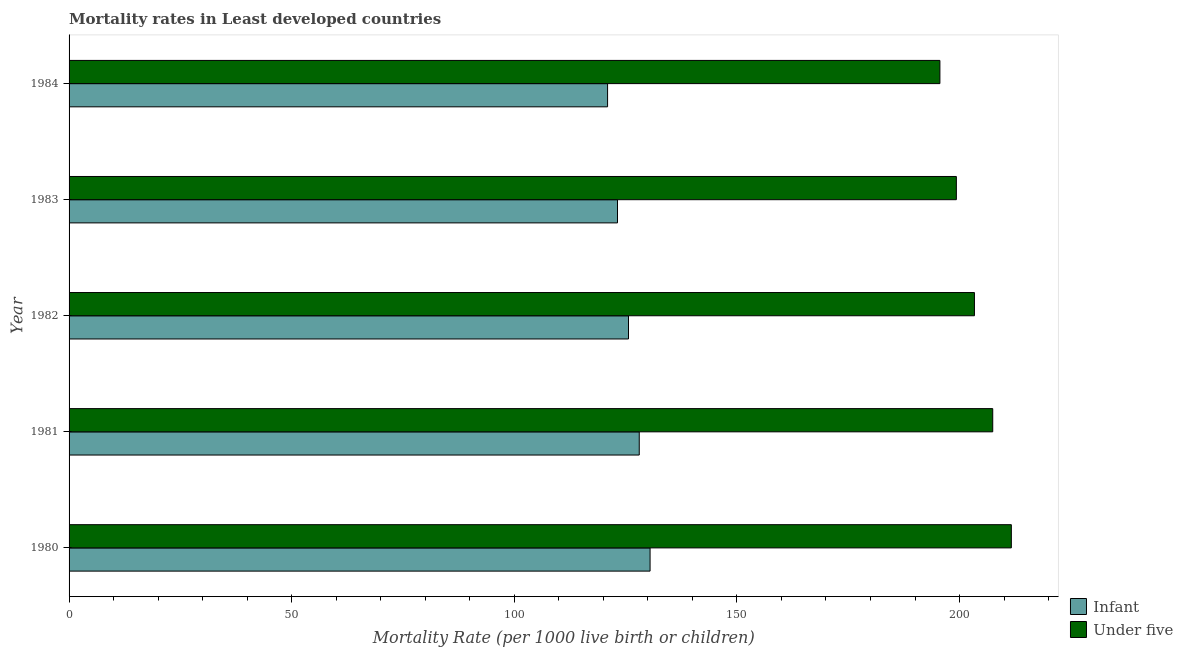How many groups of bars are there?
Your response must be concise. 5. Are the number of bars per tick equal to the number of legend labels?
Your answer should be very brief. Yes. What is the under-5 mortality rate in 1980?
Provide a short and direct response. 211.64. Across all years, what is the maximum infant mortality rate?
Ensure brevity in your answer.  130.5. Across all years, what is the minimum infant mortality rate?
Your answer should be compact. 120.95. In which year was the infant mortality rate maximum?
Ensure brevity in your answer.  1980. What is the total infant mortality rate in the graph?
Your response must be concise. 628.34. What is the difference between the under-5 mortality rate in 1980 and that in 1981?
Make the answer very short. 4.18. What is the difference between the under-5 mortality rate in 1981 and the infant mortality rate in 1984?
Your answer should be compact. 86.51. What is the average infant mortality rate per year?
Ensure brevity in your answer.  125.67. In the year 1983, what is the difference between the infant mortality rate and under-5 mortality rate?
Provide a short and direct response. -76.11. What is the ratio of the under-5 mortality rate in 1980 to that in 1981?
Provide a short and direct response. 1.02. Is the under-5 mortality rate in 1980 less than that in 1982?
Ensure brevity in your answer.  No. What is the difference between the highest and the second highest infant mortality rate?
Provide a succinct answer. 2.43. What is the difference between the highest and the lowest under-5 mortality rate?
Make the answer very short. 16.05. What does the 2nd bar from the top in 1981 represents?
Provide a short and direct response. Infant. What does the 2nd bar from the bottom in 1982 represents?
Make the answer very short. Under five. How many bars are there?
Make the answer very short. 10. Are the values on the major ticks of X-axis written in scientific E-notation?
Give a very brief answer. No. Does the graph contain any zero values?
Ensure brevity in your answer.  No. Where does the legend appear in the graph?
Your answer should be compact. Bottom right. How many legend labels are there?
Offer a terse response. 2. What is the title of the graph?
Make the answer very short. Mortality rates in Least developed countries. What is the label or title of the X-axis?
Give a very brief answer. Mortality Rate (per 1000 live birth or children). What is the Mortality Rate (per 1000 live birth or children) of Infant in 1980?
Keep it short and to the point. 130.5. What is the Mortality Rate (per 1000 live birth or children) of Under five in 1980?
Provide a succinct answer. 211.64. What is the Mortality Rate (per 1000 live birth or children) in Infant in 1981?
Ensure brevity in your answer.  128.06. What is the Mortality Rate (per 1000 live birth or children) in Under five in 1981?
Make the answer very short. 207.46. What is the Mortality Rate (per 1000 live birth or children) of Infant in 1982?
Offer a very short reply. 125.65. What is the Mortality Rate (per 1000 live birth or children) in Under five in 1982?
Offer a very short reply. 203.35. What is the Mortality Rate (per 1000 live birth or children) of Infant in 1983?
Offer a terse response. 123.18. What is the Mortality Rate (per 1000 live birth or children) in Under five in 1983?
Offer a terse response. 199.29. What is the Mortality Rate (per 1000 live birth or children) in Infant in 1984?
Give a very brief answer. 120.95. What is the Mortality Rate (per 1000 live birth or children) in Under five in 1984?
Ensure brevity in your answer.  195.59. Across all years, what is the maximum Mortality Rate (per 1000 live birth or children) in Infant?
Your answer should be compact. 130.5. Across all years, what is the maximum Mortality Rate (per 1000 live birth or children) in Under five?
Your answer should be compact. 211.64. Across all years, what is the minimum Mortality Rate (per 1000 live birth or children) of Infant?
Offer a terse response. 120.95. Across all years, what is the minimum Mortality Rate (per 1000 live birth or children) in Under five?
Offer a terse response. 195.59. What is the total Mortality Rate (per 1000 live birth or children) in Infant in the graph?
Your answer should be compact. 628.34. What is the total Mortality Rate (per 1000 live birth or children) of Under five in the graph?
Provide a succinct answer. 1017.33. What is the difference between the Mortality Rate (per 1000 live birth or children) of Infant in 1980 and that in 1981?
Provide a succinct answer. 2.43. What is the difference between the Mortality Rate (per 1000 live birth or children) of Under five in 1980 and that in 1981?
Provide a short and direct response. 4.18. What is the difference between the Mortality Rate (per 1000 live birth or children) of Infant in 1980 and that in 1982?
Your answer should be very brief. 4.85. What is the difference between the Mortality Rate (per 1000 live birth or children) of Under five in 1980 and that in 1982?
Offer a terse response. 8.29. What is the difference between the Mortality Rate (per 1000 live birth or children) of Infant in 1980 and that in 1983?
Ensure brevity in your answer.  7.32. What is the difference between the Mortality Rate (per 1000 live birth or children) of Under five in 1980 and that in 1983?
Your answer should be very brief. 12.35. What is the difference between the Mortality Rate (per 1000 live birth or children) in Infant in 1980 and that in 1984?
Offer a terse response. 9.54. What is the difference between the Mortality Rate (per 1000 live birth or children) of Under five in 1980 and that in 1984?
Your response must be concise. 16.05. What is the difference between the Mortality Rate (per 1000 live birth or children) of Infant in 1981 and that in 1982?
Offer a very short reply. 2.41. What is the difference between the Mortality Rate (per 1000 live birth or children) of Under five in 1981 and that in 1982?
Your answer should be very brief. 4.11. What is the difference between the Mortality Rate (per 1000 live birth or children) in Infant in 1981 and that in 1983?
Keep it short and to the point. 4.89. What is the difference between the Mortality Rate (per 1000 live birth or children) in Under five in 1981 and that in 1983?
Offer a terse response. 8.17. What is the difference between the Mortality Rate (per 1000 live birth or children) of Infant in 1981 and that in 1984?
Give a very brief answer. 7.11. What is the difference between the Mortality Rate (per 1000 live birth or children) in Under five in 1981 and that in 1984?
Ensure brevity in your answer.  11.87. What is the difference between the Mortality Rate (per 1000 live birth or children) of Infant in 1982 and that in 1983?
Offer a terse response. 2.47. What is the difference between the Mortality Rate (per 1000 live birth or children) of Under five in 1982 and that in 1983?
Provide a short and direct response. 4.06. What is the difference between the Mortality Rate (per 1000 live birth or children) of Infant in 1982 and that in 1984?
Provide a succinct answer. 4.7. What is the difference between the Mortality Rate (per 1000 live birth or children) in Under five in 1982 and that in 1984?
Your response must be concise. 7.76. What is the difference between the Mortality Rate (per 1000 live birth or children) of Infant in 1983 and that in 1984?
Offer a very short reply. 2.23. What is the difference between the Mortality Rate (per 1000 live birth or children) of Under five in 1983 and that in 1984?
Your answer should be compact. 3.7. What is the difference between the Mortality Rate (per 1000 live birth or children) of Infant in 1980 and the Mortality Rate (per 1000 live birth or children) of Under five in 1981?
Provide a succinct answer. -76.96. What is the difference between the Mortality Rate (per 1000 live birth or children) of Infant in 1980 and the Mortality Rate (per 1000 live birth or children) of Under five in 1982?
Make the answer very short. -72.85. What is the difference between the Mortality Rate (per 1000 live birth or children) in Infant in 1980 and the Mortality Rate (per 1000 live birth or children) in Under five in 1983?
Provide a short and direct response. -68.79. What is the difference between the Mortality Rate (per 1000 live birth or children) in Infant in 1980 and the Mortality Rate (per 1000 live birth or children) in Under five in 1984?
Keep it short and to the point. -65.1. What is the difference between the Mortality Rate (per 1000 live birth or children) in Infant in 1981 and the Mortality Rate (per 1000 live birth or children) in Under five in 1982?
Offer a terse response. -75.29. What is the difference between the Mortality Rate (per 1000 live birth or children) in Infant in 1981 and the Mortality Rate (per 1000 live birth or children) in Under five in 1983?
Your answer should be compact. -71.22. What is the difference between the Mortality Rate (per 1000 live birth or children) in Infant in 1981 and the Mortality Rate (per 1000 live birth or children) in Under five in 1984?
Your answer should be very brief. -67.53. What is the difference between the Mortality Rate (per 1000 live birth or children) of Infant in 1982 and the Mortality Rate (per 1000 live birth or children) of Under five in 1983?
Your answer should be very brief. -73.64. What is the difference between the Mortality Rate (per 1000 live birth or children) in Infant in 1982 and the Mortality Rate (per 1000 live birth or children) in Under five in 1984?
Your response must be concise. -69.94. What is the difference between the Mortality Rate (per 1000 live birth or children) of Infant in 1983 and the Mortality Rate (per 1000 live birth or children) of Under five in 1984?
Your response must be concise. -72.41. What is the average Mortality Rate (per 1000 live birth or children) in Infant per year?
Ensure brevity in your answer.  125.67. What is the average Mortality Rate (per 1000 live birth or children) in Under five per year?
Offer a terse response. 203.47. In the year 1980, what is the difference between the Mortality Rate (per 1000 live birth or children) of Infant and Mortality Rate (per 1000 live birth or children) of Under five?
Offer a very short reply. -81.14. In the year 1981, what is the difference between the Mortality Rate (per 1000 live birth or children) of Infant and Mortality Rate (per 1000 live birth or children) of Under five?
Make the answer very short. -79.39. In the year 1982, what is the difference between the Mortality Rate (per 1000 live birth or children) in Infant and Mortality Rate (per 1000 live birth or children) in Under five?
Provide a succinct answer. -77.7. In the year 1983, what is the difference between the Mortality Rate (per 1000 live birth or children) in Infant and Mortality Rate (per 1000 live birth or children) in Under five?
Your answer should be very brief. -76.11. In the year 1984, what is the difference between the Mortality Rate (per 1000 live birth or children) in Infant and Mortality Rate (per 1000 live birth or children) in Under five?
Your response must be concise. -74.64. What is the ratio of the Mortality Rate (per 1000 live birth or children) of Infant in 1980 to that in 1981?
Your answer should be compact. 1.02. What is the ratio of the Mortality Rate (per 1000 live birth or children) in Under five in 1980 to that in 1981?
Keep it short and to the point. 1.02. What is the ratio of the Mortality Rate (per 1000 live birth or children) of Infant in 1980 to that in 1982?
Your answer should be very brief. 1.04. What is the ratio of the Mortality Rate (per 1000 live birth or children) of Under five in 1980 to that in 1982?
Provide a succinct answer. 1.04. What is the ratio of the Mortality Rate (per 1000 live birth or children) of Infant in 1980 to that in 1983?
Provide a short and direct response. 1.06. What is the ratio of the Mortality Rate (per 1000 live birth or children) in Under five in 1980 to that in 1983?
Provide a short and direct response. 1.06. What is the ratio of the Mortality Rate (per 1000 live birth or children) in Infant in 1980 to that in 1984?
Offer a terse response. 1.08. What is the ratio of the Mortality Rate (per 1000 live birth or children) in Under five in 1980 to that in 1984?
Your answer should be very brief. 1.08. What is the ratio of the Mortality Rate (per 1000 live birth or children) in Infant in 1981 to that in 1982?
Give a very brief answer. 1.02. What is the ratio of the Mortality Rate (per 1000 live birth or children) in Under five in 1981 to that in 1982?
Offer a terse response. 1.02. What is the ratio of the Mortality Rate (per 1000 live birth or children) of Infant in 1981 to that in 1983?
Ensure brevity in your answer.  1.04. What is the ratio of the Mortality Rate (per 1000 live birth or children) of Under five in 1981 to that in 1983?
Keep it short and to the point. 1.04. What is the ratio of the Mortality Rate (per 1000 live birth or children) in Infant in 1981 to that in 1984?
Provide a short and direct response. 1.06. What is the ratio of the Mortality Rate (per 1000 live birth or children) of Under five in 1981 to that in 1984?
Provide a short and direct response. 1.06. What is the ratio of the Mortality Rate (per 1000 live birth or children) of Infant in 1982 to that in 1983?
Provide a succinct answer. 1.02. What is the ratio of the Mortality Rate (per 1000 live birth or children) of Under five in 1982 to that in 1983?
Ensure brevity in your answer.  1.02. What is the ratio of the Mortality Rate (per 1000 live birth or children) of Infant in 1982 to that in 1984?
Ensure brevity in your answer.  1.04. What is the ratio of the Mortality Rate (per 1000 live birth or children) in Under five in 1982 to that in 1984?
Provide a succinct answer. 1.04. What is the ratio of the Mortality Rate (per 1000 live birth or children) in Infant in 1983 to that in 1984?
Give a very brief answer. 1.02. What is the ratio of the Mortality Rate (per 1000 live birth or children) in Under five in 1983 to that in 1984?
Make the answer very short. 1.02. What is the difference between the highest and the second highest Mortality Rate (per 1000 live birth or children) in Infant?
Provide a succinct answer. 2.43. What is the difference between the highest and the second highest Mortality Rate (per 1000 live birth or children) of Under five?
Provide a short and direct response. 4.18. What is the difference between the highest and the lowest Mortality Rate (per 1000 live birth or children) in Infant?
Provide a short and direct response. 9.54. What is the difference between the highest and the lowest Mortality Rate (per 1000 live birth or children) in Under five?
Give a very brief answer. 16.05. 